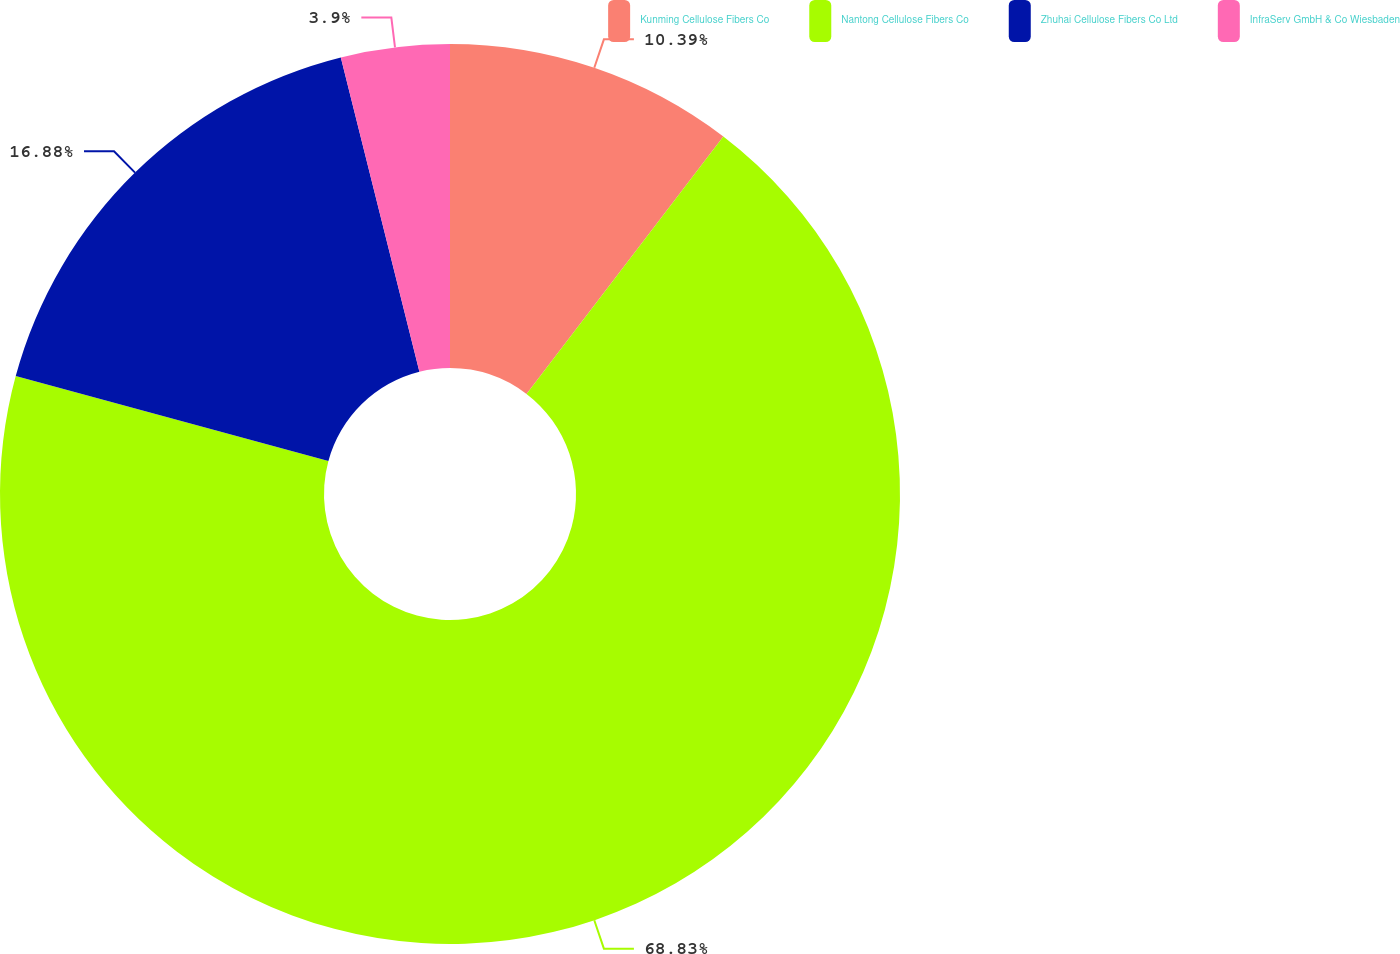<chart> <loc_0><loc_0><loc_500><loc_500><pie_chart><fcel>Kunming Cellulose Fibers Co<fcel>Nantong Cellulose Fibers Co<fcel>Zhuhai Cellulose Fibers Co Ltd<fcel>InfraServ GmbH & Co Wiesbaden<nl><fcel>10.39%<fcel>68.83%<fcel>16.88%<fcel>3.9%<nl></chart> 